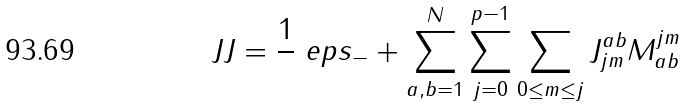<formula> <loc_0><loc_0><loc_500><loc_500>\ J J = \frac { 1 } { } \ e p s _ { - } + \sum _ { a , b = 1 } ^ { N } \sum _ { j = 0 } ^ { p - 1 } \sum _ { 0 \leq m \leq j } J _ { j m } ^ { a b } M ^ { j m } _ { a b }</formula> 